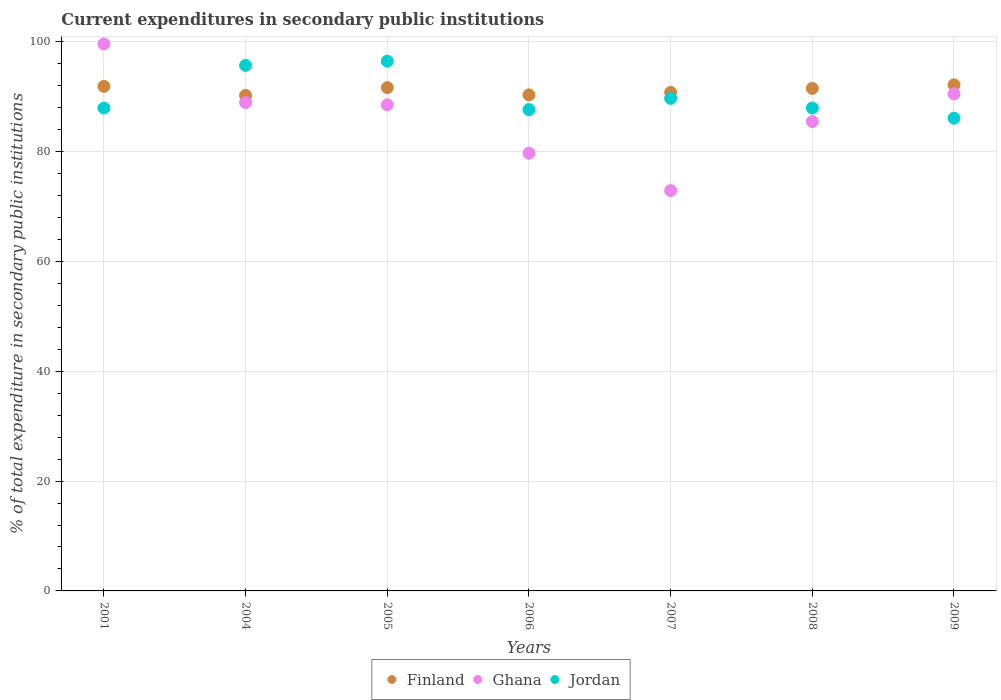What is the current expenditures in secondary public institutions in Finland in 2008?
Offer a very short reply. 91.51. Across all years, what is the maximum current expenditures in secondary public institutions in Finland?
Make the answer very short. 92.17. Across all years, what is the minimum current expenditures in secondary public institutions in Finland?
Make the answer very short. 90.24. In which year was the current expenditures in secondary public institutions in Finland maximum?
Provide a short and direct response. 2009. What is the total current expenditures in secondary public institutions in Finland in the graph?
Give a very brief answer. 638.6. What is the difference between the current expenditures in secondary public institutions in Finland in 2001 and that in 2008?
Offer a very short reply. 0.37. What is the difference between the current expenditures in secondary public institutions in Finland in 2004 and the current expenditures in secondary public institutions in Ghana in 2001?
Your answer should be very brief. -9.37. What is the average current expenditures in secondary public institutions in Jordan per year?
Provide a short and direct response. 90.21. In the year 2008, what is the difference between the current expenditures in secondary public institutions in Finland and current expenditures in secondary public institutions in Ghana?
Offer a terse response. 6.04. What is the ratio of the current expenditures in secondary public institutions in Ghana in 2005 to that in 2006?
Provide a short and direct response. 1.11. Is the current expenditures in secondary public institutions in Ghana in 2005 less than that in 2006?
Your answer should be very brief. No. What is the difference between the highest and the second highest current expenditures in secondary public institutions in Jordan?
Your response must be concise. 0.77. What is the difference between the highest and the lowest current expenditures in secondary public institutions in Ghana?
Ensure brevity in your answer.  26.71. In how many years, is the current expenditures in secondary public institutions in Finland greater than the average current expenditures in secondary public institutions in Finland taken over all years?
Offer a very short reply. 4. How many dotlines are there?
Keep it short and to the point. 3. What is the difference between two consecutive major ticks on the Y-axis?
Provide a short and direct response. 20. Does the graph contain any zero values?
Keep it short and to the point. No. Does the graph contain grids?
Provide a short and direct response. Yes. How are the legend labels stacked?
Keep it short and to the point. Horizontal. What is the title of the graph?
Make the answer very short. Current expenditures in secondary public institutions. What is the label or title of the X-axis?
Make the answer very short. Years. What is the label or title of the Y-axis?
Offer a terse response. % of total expenditure in secondary public institutions. What is the % of total expenditure in secondary public institutions in Finland in 2001?
Your answer should be very brief. 91.88. What is the % of total expenditure in secondary public institutions of Ghana in 2001?
Your answer should be very brief. 99.62. What is the % of total expenditure in secondary public institutions of Jordan in 2001?
Offer a terse response. 87.94. What is the % of total expenditure in secondary public institutions of Finland in 2004?
Give a very brief answer. 90.24. What is the % of total expenditure in secondary public institutions in Ghana in 2004?
Your answer should be very brief. 88.93. What is the % of total expenditure in secondary public institutions in Jordan in 2004?
Offer a very short reply. 95.7. What is the % of total expenditure in secondary public institutions of Finland in 2005?
Your response must be concise. 91.66. What is the % of total expenditure in secondary public institutions in Ghana in 2005?
Provide a succinct answer. 88.52. What is the % of total expenditure in secondary public institutions of Jordan in 2005?
Give a very brief answer. 96.47. What is the % of total expenditure in secondary public institutions in Finland in 2006?
Keep it short and to the point. 90.34. What is the % of total expenditure in secondary public institutions in Ghana in 2006?
Provide a succinct answer. 79.72. What is the % of total expenditure in secondary public institutions in Jordan in 2006?
Provide a short and direct response. 87.65. What is the % of total expenditure in secondary public institutions of Finland in 2007?
Your response must be concise. 90.79. What is the % of total expenditure in secondary public institutions in Ghana in 2007?
Ensure brevity in your answer.  72.91. What is the % of total expenditure in secondary public institutions of Jordan in 2007?
Your answer should be very brief. 89.68. What is the % of total expenditure in secondary public institutions of Finland in 2008?
Offer a very short reply. 91.51. What is the % of total expenditure in secondary public institutions of Ghana in 2008?
Provide a succinct answer. 85.48. What is the % of total expenditure in secondary public institutions of Jordan in 2008?
Your response must be concise. 87.94. What is the % of total expenditure in secondary public institutions of Finland in 2009?
Offer a very short reply. 92.17. What is the % of total expenditure in secondary public institutions of Ghana in 2009?
Your answer should be very brief. 90.52. What is the % of total expenditure in secondary public institutions of Jordan in 2009?
Keep it short and to the point. 86.09. Across all years, what is the maximum % of total expenditure in secondary public institutions of Finland?
Keep it short and to the point. 92.17. Across all years, what is the maximum % of total expenditure in secondary public institutions of Ghana?
Provide a short and direct response. 99.62. Across all years, what is the maximum % of total expenditure in secondary public institutions in Jordan?
Give a very brief answer. 96.47. Across all years, what is the minimum % of total expenditure in secondary public institutions in Finland?
Give a very brief answer. 90.24. Across all years, what is the minimum % of total expenditure in secondary public institutions in Ghana?
Your answer should be very brief. 72.91. Across all years, what is the minimum % of total expenditure in secondary public institutions in Jordan?
Make the answer very short. 86.09. What is the total % of total expenditure in secondary public institutions in Finland in the graph?
Offer a terse response. 638.6. What is the total % of total expenditure in secondary public institutions of Ghana in the graph?
Your answer should be compact. 605.69. What is the total % of total expenditure in secondary public institutions of Jordan in the graph?
Provide a short and direct response. 631.47. What is the difference between the % of total expenditure in secondary public institutions in Finland in 2001 and that in 2004?
Ensure brevity in your answer.  1.64. What is the difference between the % of total expenditure in secondary public institutions in Ghana in 2001 and that in 2004?
Offer a very short reply. 10.69. What is the difference between the % of total expenditure in secondary public institutions in Jordan in 2001 and that in 2004?
Keep it short and to the point. -7.76. What is the difference between the % of total expenditure in secondary public institutions of Finland in 2001 and that in 2005?
Give a very brief answer. 0.23. What is the difference between the % of total expenditure in secondary public institutions of Ghana in 2001 and that in 2005?
Keep it short and to the point. 11.09. What is the difference between the % of total expenditure in secondary public institutions of Jordan in 2001 and that in 2005?
Ensure brevity in your answer.  -8.53. What is the difference between the % of total expenditure in secondary public institutions in Finland in 2001 and that in 2006?
Offer a very short reply. 1.55. What is the difference between the % of total expenditure in secondary public institutions of Ghana in 2001 and that in 2006?
Your answer should be very brief. 19.9. What is the difference between the % of total expenditure in secondary public institutions in Jordan in 2001 and that in 2006?
Ensure brevity in your answer.  0.29. What is the difference between the % of total expenditure in secondary public institutions in Finland in 2001 and that in 2007?
Make the answer very short. 1.09. What is the difference between the % of total expenditure in secondary public institutions in Ghana in 2001 and that in 2007?
Give a very brief answer. 26.71. What is the difference between the % of total expenditure in secondary public institutions of Jordan in 2001 and that in 2007?
Ensure brevity in your answer.  -1.74. What is the difference between the % of total expenditure in secondary public institutions in Finland in 2001 and that in 2008?
Provide a short and direct response. 0.37. What is the difference between the % of total expenditure in secondary public institutions in Ghana in 2001 and that in 2008?
Keep it short and to the point. 14.14. What is the difference between the % of total expenditure in secondary public institutions of Jordan in 2001 and that in 2008?
Keep it short and to the point. -0. What is the difference between the % of total expenditure in secondary public institutions in Finland in 2001 and that in 2009?
Make the answer very short. -0.29. What is the difference between the % of total expenditure in secondary public institutions of Ghana in 2001 and that in 2009?
Give a very brief answer. 9.1. What is the difference between the % of total expenditure in secondary public institutions in Jordan in 2001 and that in 2009?
Provide a short and direct response. 1.85. What is the difference between the % of total expenditure in secondary public institutions of Finland in 2004 and that in 2005?
Make the answer very short. -1.41. What is the difference between the % of total expenditure in secondary public institutions in Ghana in 2004 and that in 2005?
Your answer should be compact. 0.4. What is the difference between the % of total expenditure in secondary public institutions in Jordan in 2004 and that in 2005?
Provide a succinct answer. -0.77. What is the difference between the % of total expenditure in secondary public institutions of Finland in 2004 and that in 2006?
Provide a succinct answer. -0.09. What is the difference between the % of total expenditure in secondary public institutions in Ghana in 2004 and that in 2006?
Offer a terse response. 9.21. What is the difference between the % of total expenditure in secondary public institutions in Jordan in 2004 and that in 2006?
Offer a very short reply. 8.05. What is the difference between the % of total expenditure in secondary public institutions in Finland in 2004 and that in 2007?
Give a very brief answer. -0.55. What is the difference between the % of total expenditure in secondary public institutions in Ghana in 2004 and that in 2007?
Give a very brief answer. 16.02. What is the difference between the % of total expenditure in secondary public institutions in Jordan in 2004 and that in 2007?
Provide a short and direct response. 6.02. What is the difference between the % of total expenditure in secondary public institutions of Finland in 2004 and that in 2008?
Provide a short and direct response. -1.27. What is the difference between the % of total expenditure in secondary public institutions of Ghana in 2004 and that in 2008?
Keep it short and to the point. 3.45. What is the difference between the % of total expenditure in secondary public institutions of Jordan in 2004 and that in 2008?
Make the answer very short. 7.76. What is the difference between the % of total expenditure in secondary public institutions of Finland in 2004 and that in 2009?
Keep it short and to the point. -1.93. What is the difference between the % of total expenditure in secondary public institutions in Ghana in 2004 and that in 2009?
Ensure brevity in your answer.  -1.59. What is the difference between the % of total expenditure in secondary public institutions of Jordan in 2004 and that in 2009?
Give a very brief answer. 9.61. What is the difference between the % of total expenditure in secondary public institutions of Finland in 2005 and that in 2006?
Provide a succinct answer. 1.32. What is the difference between the % of total expenditure in secondary public institutions of Ghana in 2005 and that in 2006?
Make the answer very short. 8.81. What is the difference between the % of total expenditure in secondary public institutions of Jordan in 2005 and that in 2006?
Offer a terse response. 8.82. What is the difference between the % of total expenditure in secondary public institutions of Finland in 2005 and that in 2007?
Your response must be concise. 0.87. What is the difference between the % of total expenditure in secondary public institutions in Ghana in 2005 and that in 2007?
Keep it short and to the point. 15.61. What is the difference between the % of total expenditure in secondary public institutions in Jordan in 2005 and that in 2007?
Keep it short and to the point. 6.79. What is the difference between the % of total expenditure in secondary public institutions of Finland in 2005 and that in 2008?
Your answer should be compact. 0.14. What is the difference between the % of total expenditure in secondary public institutions of Ghana in 2005 and that in 2008?
Offer a terse response. 3.05. What is the difference between the % of total expenditure in secondary public institutions of Jordan in 2005 and that in 2008?
Make the answer very short. 8.53. What is the difference between the % of total expenditure in secondary public institutions of Finland in 2005 and that in 2009?
Your answer should be compact. -0.52. What is the difference between the % of total expenditure in secondary public institutions in Ghana in 2005 and that in 2009?
Your answer should be compact. -2. What is the difference between the % of total expenditure in secondary public institutions in Jordan in 2005 and that in 2009?
Keep it short and to the point. 10.38. What is the difference between the % of total expenditure in secondary public institutions of Finland in 2006 and that in 2007?
Offer a terse response. -0.45. What is the difference between the % of total expenditure in secondary public institutions of Ghana in 2006 and that in 2007?
Offer a terse response. 6.81. What is the difference between the % of total expenditure in secondary public institutions of Jordan in 2006 and that in 2007?
Ensure brevity in your answer.  -2.03. What is the difference between the % of total expenditure in secondary public institutions in Finland in 2006 and that in 2008?
Your response must be concise. -1.18. What is the difference between the % of total expenditure in secondary public institutions in Ghana in 2006 and that in 2008?
Your answer should be compact. -5.76. What is the difference between the % of total expenditure in secondary public institutions of Jordan in 2006 and that in 2008?
Your answer should be compact. -0.29. What is the difference between the % of total expenditure in secondary public institutions of Finland in 2006 and that in 2009?
Ensure brevity in your answer.  -1.84. What is the difference between the % of total expenditure in secondary public institutions of Ghana in 2006 and that in 2009?
Make the answer very short. -10.8. What is the difference between the % of total expenditure in secondary public institutions of Jordan in 2006 and that in 2009?
Make the answer very short. 1.56. What is the difference between the % of total expenditure in secondary public institutions in Finland in 2007 and that in 2008?
Your response must be concise. -0.72. What is the difference between the % of total expenditure in secondary public institutions in Ghana in 2007 and that in 2008?
Ensure brevity in your answer.  -12.57. What is the difference between the % of total expenditure in secondary public institutions in Jordan in 2007 and that in 2008?
Offer a terse response. 1.74. What is the difference between the % of total expenditure in secondary public institutions of Finland in 2007 and that in 2009?
Keep it short and to the point. -1.38. What is the difference between the % of total expenditure in secondary public institutions of Ghana in 2007 and that in 2009?
Your answer should be compact. -17.61. What is the difference between the % of total expenditure in secondary public institutions in Jordan in 2007 and that in 2009?
Offer a very short reply. 3.59. What is the difference between the % of total expenditure in secondary public institutions of Finland in 2008 and that in 2009?
Make the answer very short. -0.66. What is the difference between the % of total expenditure in secondary public institutions of Ghana in 2008 and that in 2009?
Provide a succinct answer. -5.04. What is the difference between the % of total expenditure in secondary public institutions in Jordan in 2008 and that in 2009?
Your response must be concise. 1.85. What is the difference between the % of total expenditure in secondary public institutions in Finland in 2001 and the % of total expenditure in secondary public institutions in Ghana in 2004?
Provide a succinct answer. 2.96. What is the difference between the % of total expenditure in secondary public institutions of Finland in 2001 and the % of total expenditure in secondary public institutions of Jordan in 2004?
Your answer should be compact. -3.82. What is the difference between the % of total expenditure in secondary public institutions in Ghana in 2001 and the % of total expenditure in secondary public institutions in Jordan in 2004?
Provide a succinct answer. 3.92. What is the difference between the % of total expenditure in secondary public institutions of Finland in 2001 and the % of total expenditure in secondary public institutions of Ghana in 2005?
Provide a short and direct response. 3.36. What is the difference between the % of total expenditure in secondary public institutions of Finland in 2001 and the % of total expenditure in secondary public institutions of Jordan in 2005?
Provide a short and direct response. -4.59. What is the difference between the % of total expenditure in secondary public institutions in Ghana in 2001 and the % of total expenditure in secondary public institutions in Jordan in 2005?
Provide a succinct answer. 3.15. What is the difference between the % of total expenditure in secondary public institutions in Finland in 2001 and the % of total expenditure in secondary public institutions in Ghana in 2006?
Make the answer very short. 12.17. What is the difference between the % of total expenditure in secondary public institutions of Finland in 2001 and the % of total expenditure in secondary public institutions of Jordan in 2006?
Make the answer very short. 4.23. What is the difference between the % of total expenditure in secondary public institutions in Ghana in 2001 and the % of total expenditure in secondary public institutions in Jordan in 2006?
Offer a terse response. 11.97. What is the difference between the % of total expenditure in secondary public institutions in Finland in 2001 and the % of total expenditure in secondary public institutions in Ghana in 2007?
Your response must be concise. 18.97. What is the difference between the % of total expenditure in secondary public institutions of Finland in 2001 and the % of total expenditure in secondary public institutions of Jordan in 2007?
Your answer should be compact. 2.2. What is the difference between the % of total expenditure in secondary public institutions in Ghana in 2001 and the % of total expenditure in secondary public institutions in Jordan in 2007?
Offer a very short reply. 9.93. What is the difference between the % of total expenditure in secondary public institutions in Finland in 2001 and the % of total expenditure in secondary public institutions in Ghana in 2008?
Provide a short and direct response. 6.41. What is the difference between the % of total expenditure in secondary public institutions in Finland in 2001 and the % of total expenditure in secondary public institutions in Jordan in 2008?
Your answer should be compact. 3.94. What is the difference between the % of total expenditure in secondary public institutions of Ghana in 2001 and the % of total expenditure in secondary public institutions of Jordan in 2008?
Provide a short and direct response. 11.68. What is the difference between the % of total expenditure in secondary public institutions in Finland in 2001 and the % of total expenditure in secondary public institutions in Ghana in 2009?
Make the answer very short. 1.36. What is the difference between the % of total expenditure in secondary public institutions in Finland in 2001 and the % of total expenditure in secondary public institutions in Jordan in 2009?
Offer a terse response. 5.79. What is the difference between the % of total expenditure in secondary public institutions of Ghana in 2001 and the % of total expenditure in secondary public institutions of Jordan in 2009?
Make the answer very short. 13.53. What is the difference between the % of total expenditure in secondary public institutions in Finland in 2004 and the % of total expenditure in secondary public institutions in Ghana in 2005?
Your answer should be very brief. 1.72. What is the difference between the % of total expenditure in secondary public institutions of Finland in 2004 and the % of total expenditure in secondary public institutions of Jordan in 2005?
Make the answer very short. -6.23. What is the difference between the % of total expenditure in secondary public institutions of Ghana in 2004 and the % of total expenditure in secondary public institutions of Jordan in 2005?
Your response must be concise. -7.54. What is the difference between the % of total expenditure in secondary public institutions of Finland in 2004 and the % of total expenditure in secondary public institutions of Ghana in 2006?
Keep it short and to the point. 10.53. What is the difference between the % of total expenditure in secondary public institutions in Finland in 2004 and the % of total expenditure in secondary public institutions in Jordan in 2006?
Provide a succinct answer. 2.59. What is the difference between the % of total expenditure in secondary public institutions in Ghana in 2004 and the % of total expenditure in secondary public institutions in Jordan in 2006?
Give a very brief answer. 1.28. What is the difference between the % of total expenditure in secondary public institutions of Finland in 2004 and the % of total expenditure in secondary public institutions of Ghana in 2007?
Provide a succinct answer. 17.33. What is the difference between the % of total expenditure in secondary public institutions in Finland in 2004 and the % of total expenditure in secondary public institutions in Jordan in 2007?
Offer a very short reply. 0.56. What is the difference between the % of total expenditure in secondary public institutions of Ghana in 2004 and the % of total expenditure in secondary public institutions of Jordan in 2007?
Your answer should be very brief. -0.76. What is the difference between the % of total expenditure in secondary public institutions in Finland in 2004 and the % of total expenditure in secondary public institutions in Ghana in 2008?
Provide a succinct answer. 4.77. What is the difference between the % of total expenditure in secondary public institutions in Finland in 2004 and the % of total expenditure in secondary public institutions in Jordan in 2008?
Your answer should be compact. 2.3. What is the difference between the % of total expenditure in secondary public institutions in Ghana in 2004 and the % of total expenditure in secondary public institutions in Jordan in 2008?
Make the answer very short. 0.99. What is the difference between the % of total expenditure in secondary public institutions in Finland in 2004 and the % of total expenditure in secondary public institutions in Ghana in 2009?
Your answer should be compact. -0.28. What is the difference between the % of total expenditure in secondary public institutions in Finland in 2004 and the % of total expenditure in secondary public institutions in Jordan in 2009?
Your answer should be compact. 4.15. What is the difference between the % of total expenditure in secondary public institutions of Ghana in 2004 and the % of total expenditure in secondary public institutions of Jordan in 2009?
Make the answer very short. 2.84. What is the difference between the % of total expenditure in secondary public institutions of Finland in 2005 and the % of total expenditure in secondary public institutions of Ghana in 2006?
Give a very brief answer. 11.94. What is the difference between the % of total expenditure in secondary public institutions in Finland in 2005 and the % of total expenditure in secondary public institutions in Jordan in 2006?
Provide a short and direct response. 4.01. What is the difference between the % of total expenditure in secondary public institutions in Ghana in 2005 and the % of total expenditure in secondary public institutions in Jordan in 2006?
Ensure brevity in your answer.  0.87. What is the difference between the % of total expenditure in secondary public institutions in Finland in 2005 and the % of total expenditure in secondary public institutions in Ghana in 2007?
Give a very brief answer. 18.75. What is the difference between the % of total expenditure in secondary public institutions in Finland in 2005 and the % of total expenditure in secondary public institutions in Jordan in 2007?
Keep it short and to the point. 1.97. What is the difference between the % of total expenditure in secondary public institutions of Ghana in 2005 and the % of total expenditure in secondary public institutions of Jordan in 2007?
Keep it short and to the point. -1.16. What is the difference between the % of total expenditure in secondary public institutions in Finland in 2005 and the % of total expenditure in secondary public institutions in Ghana in 2008?
Your answer should be compact. 6.18. What is the difference between the % of total expenditure in secondary public institutions of Finland in 2005 and the % of total expenditure in secondary public institutions of Jordan in 2008?
Offer a terse response. 3.72. What is the difference between the % of total expenditure in secondary public institutions of Ghana in 2005 and the % of total expenditure in secondary public institutions of Jordan in 2008?
Ensure brevity in your answer.  0.58. What is the difference between the % of total expenditure in secondary public institutions of Finland in 2005 and the % of total expenditure in secondary public institutions of Ghana in 2009?
Make the answer very short. 1.14. What is the difference between the % of total expenditure in secondary public institutions in Finland in 2005 and the % of total expenditure in secondary public institutions in Jordan in 2009?
Your answer should be very brief. 5.57. What is the difference between the % of total expenditure in secondary public institutions of Ghana in 2005 and the % of total expenditure in secondary public institutions of Jordan in 2009?
Ensure brevity in your answer.  2.43. What is the difference between the % of total expenditure in secondary public institutions of Finland in 2006 and the % of total expenditure in secondary public institutions of Ghana in 2007?
Your answer should be compact. 17.43. What is the difference between the % of total expenditure in secondary public institutions of Finland in 2006 and the % of total expenditure in secondary public institutions of Jordan in 2007?
Ensure brevity in your answer.  0.65. What is the difference between the % of total expenditure in secondary public institutions of Ghana in 2006 and the % of total expenditure in secondary public institutions of Jordan in 2007?
Give a very brief answer. -9.97. What is the difference between the % of total expenditure in secondary public institutions in Finland in 2006 and the % of total expenditure in secondary public institutions in Ghana in 2008?
Provide a short and direct response. 4.86. What is the difference between the % of total expenditure in secondary public institutions in Finland in 2006 and the % of total expenditure in secondary public institutions in Jordan in 2008?
Keep it short and to the point. 2.4. What is the difference between the % of total expenditure in secondary public institutions in Ghana in 2006 and the % of total expenditure in secondary public institutions in Jordan in 2008?
Offer a very short reply. -8.22. What is the difference between the % of total expenditure in secondary public institutions in Finland in 2006 and the % of total expenditure in secondary public institutions in Ghana in 2009?
Make the answer very short. -0.18. What is the difference between the % of total expenditure in secondary public institutions in Finland in 2006 and the % of total expenditure in secondary public institutions in Jordan in 2009?
Provide a succinct answer. 4.25. What is the difference between the % of total expenditure in secondary public institutions of Ghana in 2006 and the % of total expenditure in secondary public institutions of Jordan in 2009?
Keep it short and to the point. -6.38. What is the difference between the % of total expenditure in secondary public institutions in Finland in 2007 and the % of total expenditure in secondary public institutions in Ghana in 2008?
Make the answer very short. 5.31. What is the difference between the % of total expenditure in secondary public institutions of Finland in 2007 and the % of total expenditure in secondary public institutions of Jordan in 2008?
Your answer should be compact. 2.85. What is the difference between the % of total expenditure in secondary public institutions in Ghana in 2007 and the % of total expenditure in secondary public institutions in Jordan in 2008?
Give a very brief answer. -15.03. What is the difference between the % of total expenditure in secondary public institutions in Finland in 2007 and the % of total expenditure in secondary public institutions in Ghana in 2009?
Your response must be concise. 0.27. What is the difference between the % of total expenditure in secondary public institutions of Finland in 2007 and the % of total expenditure in secondary public institutions of Jordan in 2009?
Your answer should be very brief. 4.7. What is the difference between the % of total expenditure in secondary public institutions of Ghana in 2007 and the % of total expenditure in secondary public institutions of Jordan in 2009?
Ensure brevity in your answer.  -13.18. What is the difference between the % of total expenditure in secondary public institutions of Finland in 2008 and the % of total expenditure in secondary public institutions of Jordan in 2009?
Your response must be concise. 5.42. What is the difference between the % of total expenditure in secondary public institutions of Ghana in 2008 and the % of total expenditure in secondary public institutions of Jordan in 2009?
Provide a short and direct response. -0.61. What is the average % of total expenditure in secondary public institutions of Finland per year?
Ensure brevity in your answer.  91.23. What is the average % of total expenditure in secondary public institutions in Ghana per year?
Your answer should be compact. 86.53. What is the average % of total expenditure in secondary public institutions in Jordan per year?
Give a very brief answer. 90.21. In the year 2001, what is the difference between the % of total expenditure in secondary public institutions in Finland and % of total expenditure in secondary public institutions in Ghana?
Your answer should be very brief. -7.73. In the year 2001, what is the difference between the % of total expenditure in secondary public institutions of Finland and % of total expenditure in secondary public institutions of Jordan?
Make the answer very short. 3.94. In the year 2001, what is the difference between the % of total expenditure in secondary public institutions of Ghana and % of total expenditure in secondary public institutions of Jordan?
Make the answer very short. 11.68. In the year 2004, what is the difference between the % of total expenditure in secondary public institutions of Finland and % of total expenditure in secondary public institutions of Ghana?
Provide a succinct answer. 1.32. In the year 2004, what is the difference between the % of total expenditure in secondary public institutions in Finland and % of total expenditure in secondary public institutions in Jordan?
Keep it short and to the point. -5.46. In the year 2004, what is the difference between the % of total expenditure in secondary public institutions in Ghana and % of total expenditure in secondary public institutions in Jordan?
Your answer should be compact. -6.77. In the year 2005, what is the difference between the % of total expenditure in secondary public institutions of Finland and % of total expenditure in secondary public institutions of Ghana?
Offer a terse response. 3.13. In the year 2005, what is the difference between the % of total expenditure in secondary public institutions in Finland and % of total expenditure in secondary public institutions in Jordan?
Make the answer very short. -4.81. In the year 2005, what is the difference between the % of total expenditure in secondary public institutions in Ghana and % of total expenditure in secondary public institutions in Jordan?
Your response must be concise. -7.95. In the year 2006, what is the difference between the % of total expenditure in secondary public institutions of Finland and % of total expenditure in secondary public institutions of Ghana?
Your response must be concise. 10.62. In the year 2006, what is the difference between the % of total expenditure in secondary public institutions of Finland and % of total expenditure in secondary public institutions of Jordan?
Provide a succinct answer. 2.69. In the year 2006, what is the difference between the % of total expenditure in secondary public institutions in Ghana and % of total expenditure in secondary public institutions in Jordan?
Your answer should be very brief. -7.93. In the year 2007, what is the difference between the % of total expenditure in secondary public institutions of Finland and % of total expenditure in secondary public institutions of Ghana?
Your answer should be very brief. 17.88. In the year 2007, what is the difference between the % of total expenditure in secondary public institutions in Finland and % of total expenditure in secondary public institutions in Jordan?
Offer a terse response. 1.11. In the year 2007, what is the difference between the % of total expenditure in secondary public institutions in Ghana and % of total expenditure in secondary public institutions in Jordan?
Your answer should be compact. -16.77. In the year 2008, what is the difference between the % of total expenditure in secondary public institutions in Finland and % of total expenditure in secondary public institutions in Ghana?
Provide a succinct answer. 6.04. In the year 2008, what is the difference between the % of total expenditure in secondary public institutions in Finland and % of total expenditure in secondary public institutions in Jordan?
Offer a very short reply. 3.57. In the year 2008, what is the difference between the % of total expenditure in secondary public institutions of Ghana and % of total expenditure in secondary public institutions of Jordan?
Offer a very short reply. -2.46. In the year 2009, what is the difference between the % of total expenditure in secondary public institutions in Finland and % of total expenditure in secondary public institutions in Ghana?
Your answer should be very brief. 1.65. In the year 2009, what is the difference between the % of total expenditure in secondary public institutions of Finland and % of total expenditure in secondary public institutions of Jordan?
Your answer should be very brief. 6.08. In the year 2009, what is the difference between the % of total expenditure in secondary public institutions of Ghana and % of total expenditure in secondary public institutions of Jordan?
Make the answer very short. 4.43. What is the ratio of the % of total expenditure in secondary public institutions in Finland in 2001 to that in 2004?
Your answer should be very brief. 1.02. What is the ratio of the % of total expenditure in secondary public institutions of Ghana in 2001 to that in 2004?
Give a very brief answer. 1.12. What is the ratio of the % of total expenditure in secondary public institutions in Jordan in 2001 to that in 2004?
Offer a very short reply. 0.92. What is the ratio of the % of total expenditure in secondary public institutions in Finland in 2001 to that in 2005?
Ensure brevity in your answer.  1. What is the ratio of the % of total expenditure in secondary public institutions of Ghana in 2001 to that in 2005?
Offer a terse response. 1.13. What is the ratio of the % of total expenditure in secondary public institutions in Jordan in 2001 to that in 2005?
Provide a succinct answer. 0.91. What is the ratio of the % of total expenditure in secondary public institutions of Finland in 2001 to that in 2006?
Give a very brief answer. 1.02. What is the ratio of the % of total expenditure in secondary public institutions of Ghana in 2001 to that in 2006?
Provide a succinct answer. 1.25. What is the ratio of the % of total expenditure in secondary public institutions of Jordan in 2001 to that in 2006?
Give a very brief answer. 1. What is the ratio of the % of total expenditure in secondary public institutions of Finland in 2001 to that in 2007?
Give a very brief answer. 1.01. What is the ratio of the % of total expenditure in secondary public institutions of Ghana in 2001 to that in 2007?
Offer a terse response. 1.37. What is the ratio of the % of total expenditure in secondary public institutions in Jordan in 2001 to that in 2007?
Offer a very short reply. 0.98. What is the ratio of the % of total expenditure in secondary public institutions of Finland in 2001 to that in 2008?
Provide a succinct answer. 1. What is the ratio of the % of total expenditure in secondary public institutions of Ghana in 2001 to that in 2008?
Your answer should be compact. 1.17. What is the ratio of the % of total expenditure in secondary public institutions of Finland in 2001 to that in 2009?
Provide a short and direct response. 1. What is the ratio of the % of total expenditure in secondary public institutions in Ghana in 2001 to that in 2009?
Offer a terse response. 1.1. What is the ratio of the % of total expenditure in secondary public institutions of Jordan in 2001 to that in 2009?
Your response must be concise. 1.02. What is the ratio of the % of total expenditure in secondary public institutions of Finland in 2004 to that in 2005?
Your answer should be compact. 0.98. What is the ratio of the % of total expenditure in secondary public institutions in Jordan in 2004 to that in 2005?
Offer a terse response. 0.99. What is the ratio of the % of total expenditure in secondary public institutions of Ghana in 2004 to that in 2006?
Keep it short and to the point. 1.12. What is the ratio of the % of total expenditure in secondary public institutions in Jordan in 2004 to that in 2006?
Offer a terse response. 1.09. What is the ratio of the % of total expenditure in secondary public institutions in Finland in 2004 to that in 2007?
Ensure brevity in your answer.  0.99. What is the ratio of the % of total expenditure in secondary public institutions of Ghana in 2004 to that in 2007?
Provide a short and direct response. 1.22. What is the ratio of the % of total expenditure in secondary public institutions of Jordan in 2004 to that in 2007?
Your response must be concise. 1.07. What is the ratio of the % of total expenditure in secondary public institutions of Finland in 2004 to that in 2008?
Your answer should be very brief. 0.99. What is the ratio of the % of total expenditure in secondary public institutions of Ghana in 2004 to that in 2008?
Provide a succinct answer. 1.04. What is the ratio of the % of total expenditure in secondary public institutions of Jordan in 2004 to that in 2008?
Your answer should be very brief. 1.09. What is the ratio of the % of total expenditure in secondary public institutions in Finland in 2004 to that in 2009?
Make the answer very short. 0.98. What is the ratio of the % of total expenditure in secondary public institutions in Ghana in 2004 to that in 2009?
Offer a terse response. 0.98. What is the ratio of the % of total expenditure in secondary public institutions of Jordan in 2004 to that in 2009?
Your answer should be compact. 1.11. What is the ratio of the % of total expenditure in secondary public institutions in Finland in 2005 to that in 2006?
Your response must be concise. 1.01. What is the ratio of the % of total expenditure in secondary public institutions of Ghana in 2005 to that in 2006?
Ensure brevity in your answer.  1.11. What is the ratio of the % of total expenditure in secondary public institutions in Jordan in 2005 to that in 2006?
Provide a succinct answer. 1.1. What is the ratio of the % of total expenditure in secondary public institutions in Finland in 2005 to that in 2007?
Your response must be concise. 1.01. What is the ratio of the % of total expenditure in secondary public institutions of Ghana in 2005 to that in 2007?
Provide a short and direct response. 1.21. What is the ratio of the % of total expenditure in secondary public institutions in Jordan in 2005 to that in 2007?
Provide a succinct answer. 1.08. What is the ratio of the % of total expenditure in secondary public institutions in Ghana in 2005 to that in 2008?
Provide a succinct answer. 1.04. What is the ratio of the % of total expenditure in secondary public institutions of Jordan in 2005 to that in 2008?
Your response must be concise. 1.1. What is the ratio of the % of total expenditure in secondary public institutions of Finland in 2005 to that in 2009?
Your answer should be compact. 0.99. What is the ratio of the % of total expenditure in secondary public institutions in Ghana in 2005 to that in 2009?
Provide a short and direct response. 0.98. What is the ratio of the % of total expenditure in secondary public institutions in Jordan in 2005 to that in 2009?
Give a very brief answer. 1.12. What is the ratio of the % of total expenditure in secondary public institutions of Finland in 2006 to that in 2007?
Offer a very short reply. 0.99. What is the ratio of the % of total expenditure in secondary public institutions in Ghana in 2006 to that in 2007?
Provide a short and direct response. 1.09. What is the ratio of the % of total expenditure in secondary public institutions in Jordan in 2006 to that in 2007?
Your answer should be very brief. 0.98. What is the ratio of the % of total expenditure in secondary public institutions in Finland in 2006 to that in 2008?
Give a very brief answer. 0.99. What is the ratio of the % of total expenditure in secondary public institutions in Ghana in 2006 to that in 2008?
Your answer should be compact. 0.93. What is the ratio of the % of total expenditure in secondary public institutions in Jordan in 2006 to that in 2008?
Offer a very short reply. 1. What is the ratio of the % of total expenditure in secondary public institutions in Finland in 2006 to that in 2009?
Your response must be concise. 0.98. What is the ratio of the % of total expenditure in secondary public institutions of Ghana in 2006 to that in 2009?
Your answer should be compact. 0.88. What is the ratio of the % of total expenditure in secondary public institutions of Jordan in 2006 to that in 2009?
Offer a very short reply. 1.02. What is the ratio of the % of total expenditure in secondary public institutions of Ghana in 2007 to that in 2008?
Your response must be concise. 0.85. What is the ratio of the % of total expenditure in secondary public institutions of Jordan in 2007 to that in 2008?
Keep it short and to the point. 1.02. What is the ratio of the % of total expenditure in secondary public institutions of Ghana in 2007 to that in 2009?
Your answer should be very brief. 0.81. What is the ratio of the % of total expenditure in secondary public institutions in Jordan in 2007 to that in 2009?
Make the answer very short. 1.04. What is the ratio of the % of total expenditure in secondary public institutions of Ghana in 2008 to that in 2009?
Give a very brief answer. 0.94. What is the ratio of the % of total expenditure in secondary public institutions in Jordan in 2008 to that in 2009?
Make the answer very short. 1.02. What is the difference between the highest and the second highest % of total expenditure in secondary public institutions in Finland?
Your answer should be compact. 0.29. What is the difference between the highest and the second highest % of total expenditure in secondary public institutions in Ghana?
Give a very brief answer. 9.1. What is the difference between the highest and the second highest % of total expenditure in secondary public institutions in Jordan?
Make the answer very short. 0.77. What is the difference between the highest and the lowest % of total expenditure in secondary public institutions in Finland?
Make the answer very short. 1.93. What is the difference between the highest and the lowest % of total expenditure in secondary public institutions in Ghana?
Keep it short and to the point. 26.71. What is the difference between the highest and the lowest % of total expenditure in secondary public institutions of Jordan?
Offer a very short reply. 10.38. 